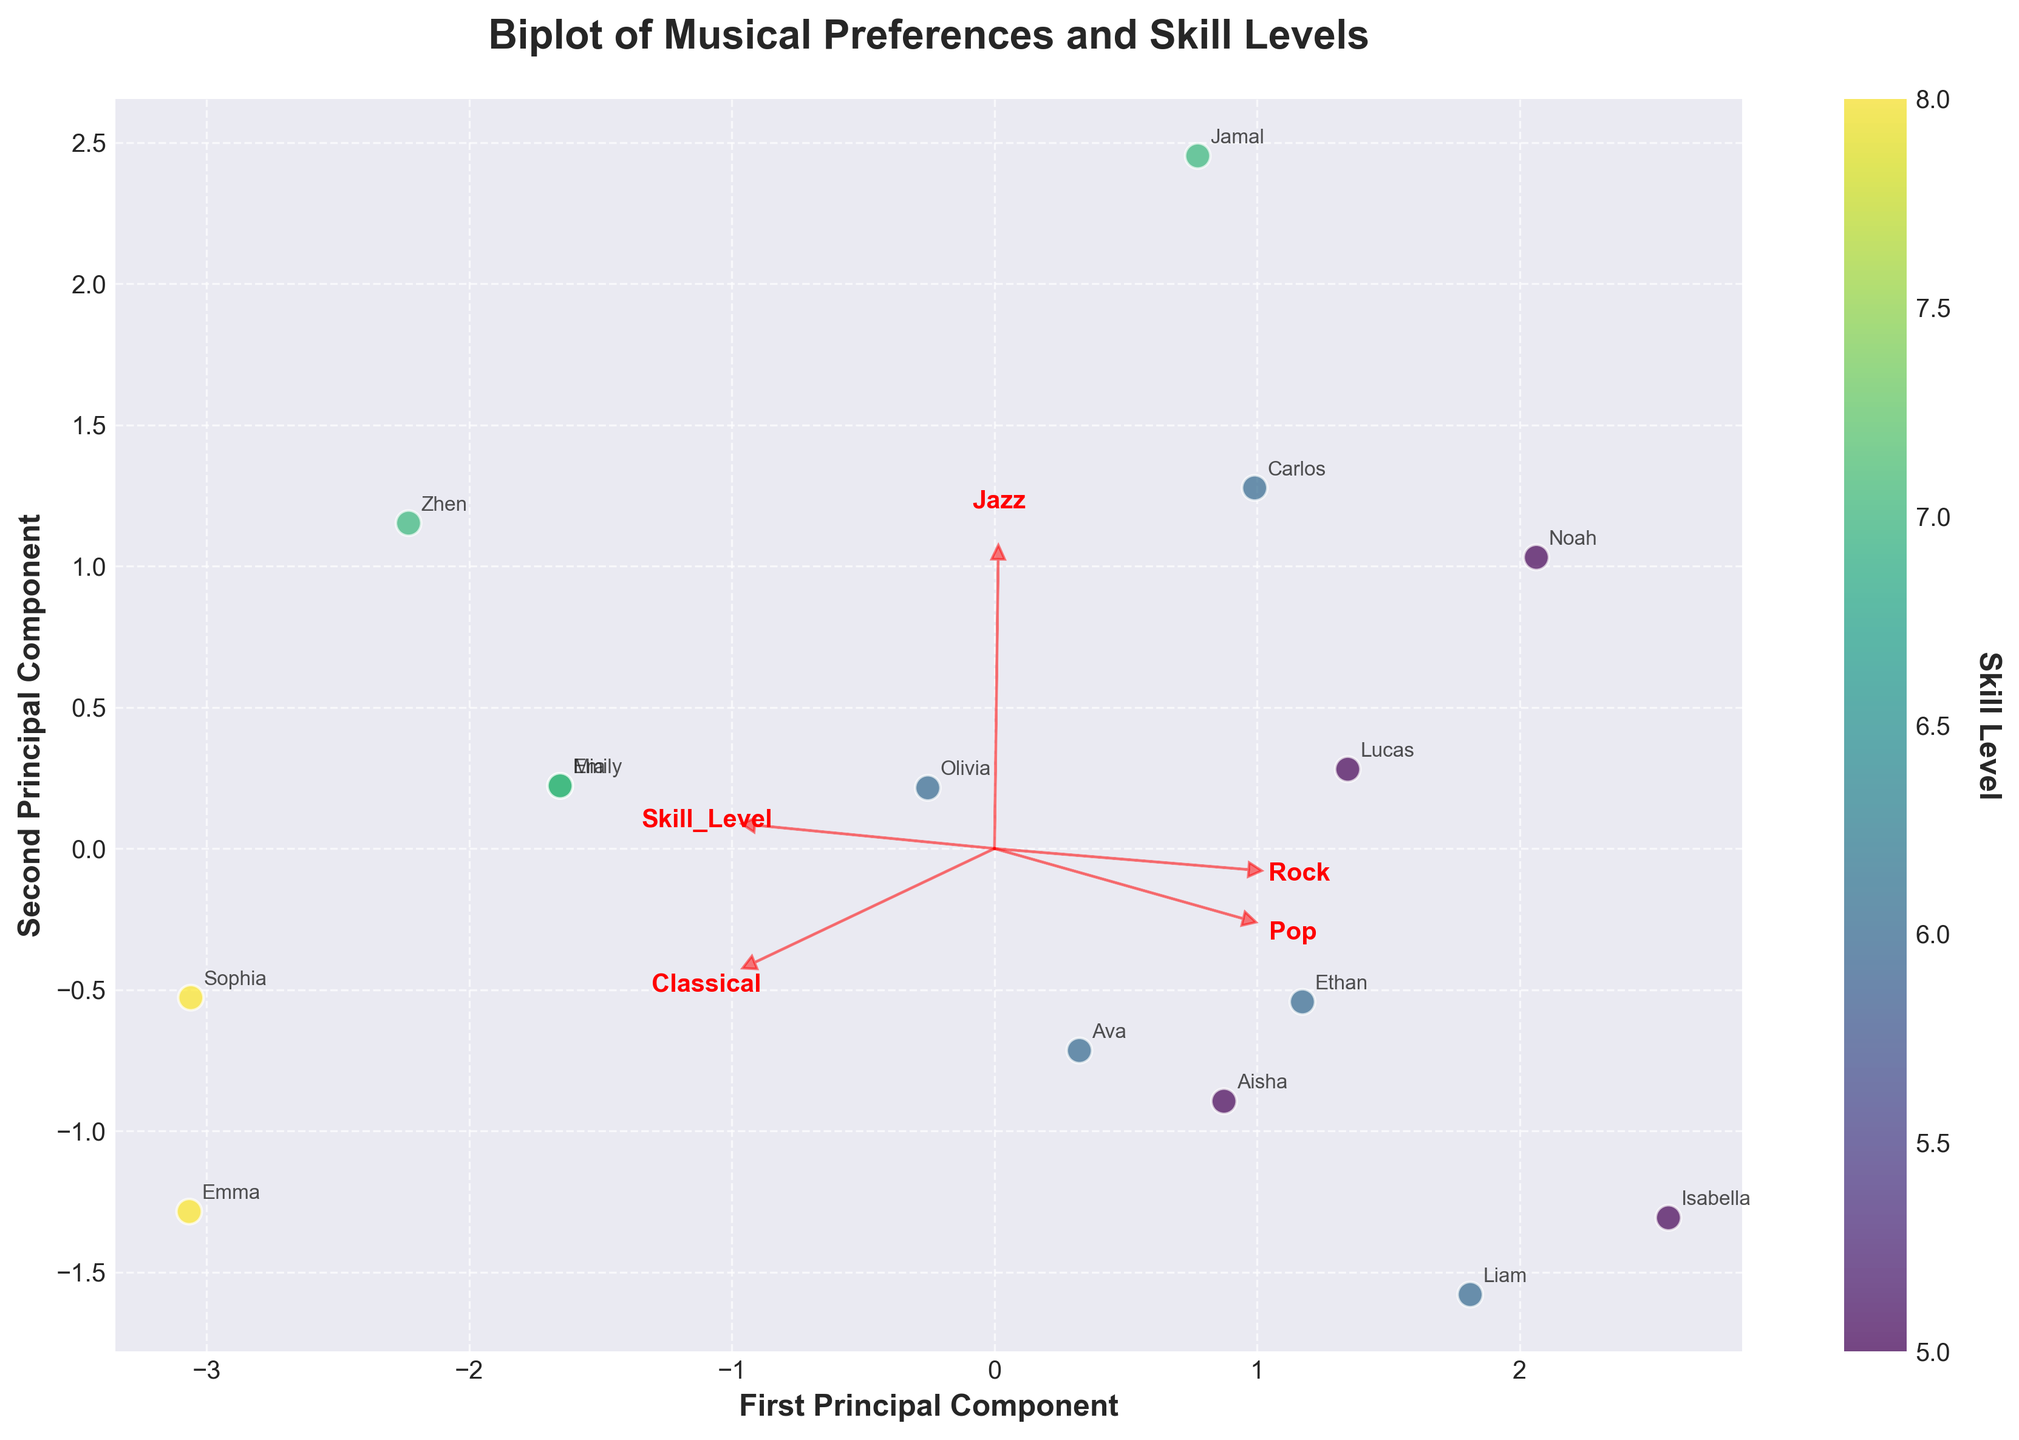What is the title of the plot? The title is shown at the top of the plot.
Answer: Biplot of Musical Preferences and Skill Levels What does the color of the points represent? The color of the points is indicated by the colorbar on the side of the plot.
Answer: Skill Level How many principal components are displayed on the plot? The plot has two labeled axes: 'First Principal Component' and 'Second Principal Component'.
Answer: 2 What musical genre is represented by the arrow pointing the most horizontally to the right? This can be identified by locating the most horizontally right-pointing arrow and reading the label next to it.
Answer: Classical Which student has the highest skill level, as indicated by the color of their point? The colorbar shows that darker shades represent higher skill levels. Find the point with the darkest color and its associated label.
Answer: Emma Do any two students have the same position on the plot? By visually inspecting the positions of points and their annotations, you can check if any overlap.
Answer: No Which feature has the most vertical arrow? Identify the arrow that is most vertical by its direction and read the label.
Answer: Rock Are students with higher skill levels closer to any specific genre? Dark-colored points (indicating higher skill levels) should be observed in relation to the arrows representing genres.
Answer: Classical Which student has preferences closest to the 'Pop' genre? Locate the direction of the 'Pop' arrow and find the nearest point to it.
Answer: Liam How are the preferences for 'Jazz' and 'Rock' related? Compare the directions of the arrows for 'Jazz' and 'Rock' to understand their correlation.
Answer: Positively associated 